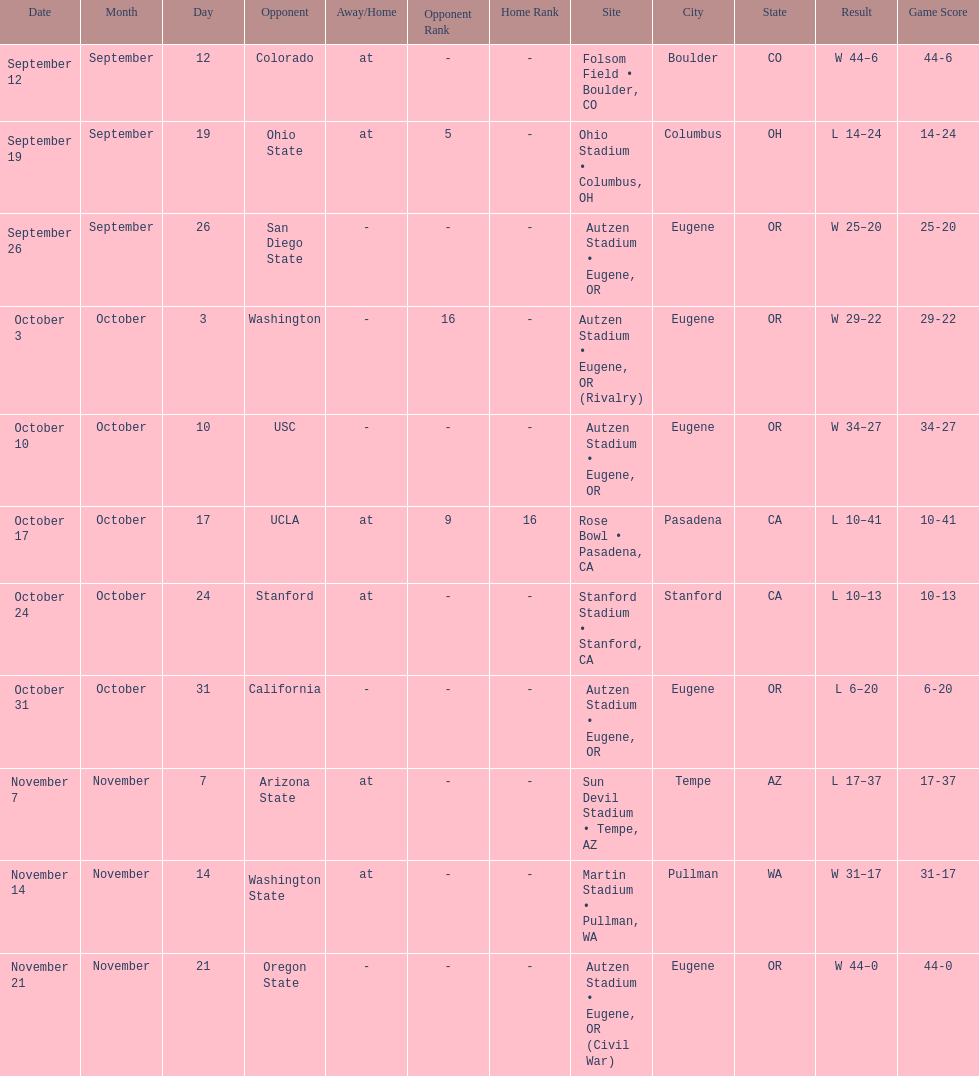How many games did the team win while not at home? 2. 